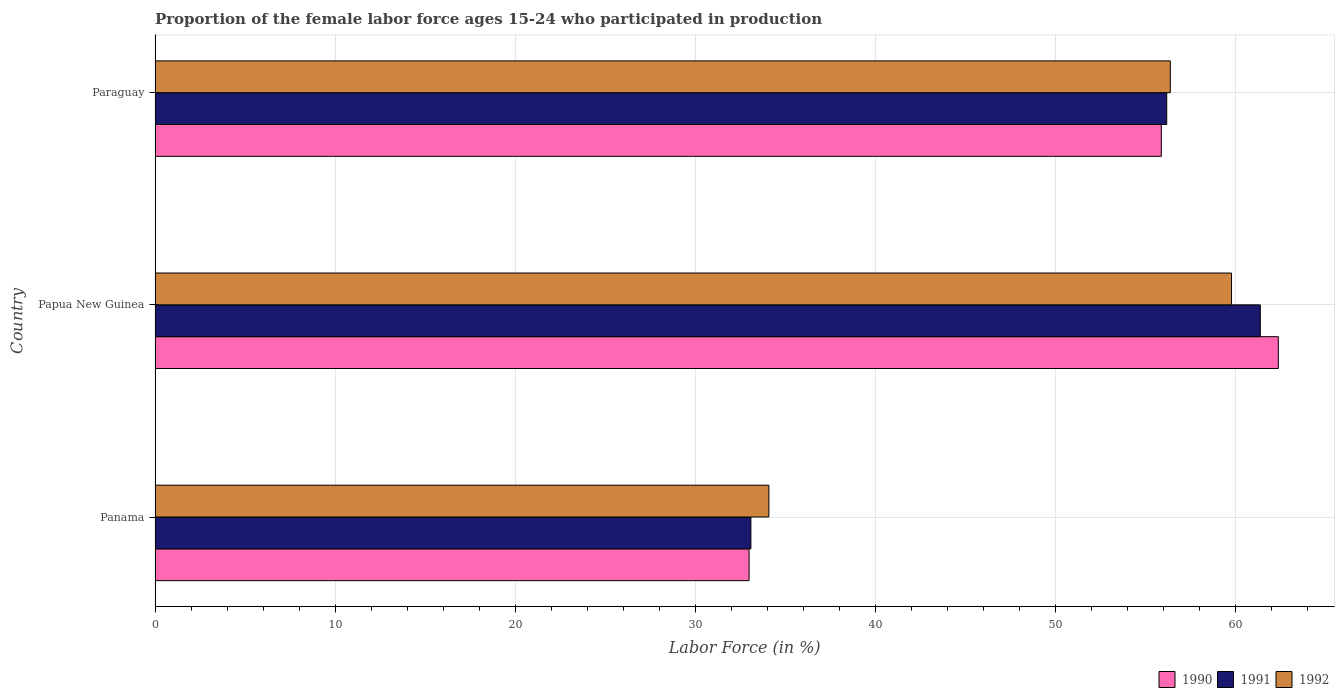How many different coloured bars are there?
Your answer should be very brief. 3. How many groups of bars are there?
Make the answer very short. 3. Are the number of bars per tick equal to the number of legend labels?
Offer a very short reply. Yes. How many bars are there on the 1st tick from the top?
Keep it short and to the point. 3. How many bars are there on the 1st tick from the bottom?
Make the answer very short. 3. What is the label of the 1st group of bars from the top?
Your answer should be compact. Paraguay. In how many cases, is the number of bars for a given country not equal to the number of legend labels?
Your response must be concise. 0. What is the proportion of the female labor force who participated in production in 1992 in Panama?
Make the answer very short. 34.1. Across all countries, what is the maximum proportion of the female labor force who participated in production in 1992?
Provide a short and direct response. 59.8. Across all countries, what is the minimum proportion of the female labor force who participated in production in 1990?
Your response must be concise. 33. In which country was the proportion of the female labor force who participated in production in 1991 maximum?
Your answer should be compact. Papua New Guinea. In which country was the proportion of the female labor force who participated in production in 1992 minimum?
Your response must be concise. Panama. What is the total proportion of the female labor force who participated in production in 1991 in the graph?
Your answer should be compact. 150.7. What is the difference between the proportion of the female labor force who participated in production in 1991 in Papua New Guinea and that in Paraguay?
Your answer should be compact. 5.2. What is the difference between the proportion of the female labor force who participated in production in 1990 in Panama and the proportion of the female labor force who participated in production in 1991 in Papua New Guinea?
Give a very brief answer. -28.4. What is the average proportion of the female labor force who participated in production in 1992 per country?
Offer a terse response. 50.1. What is the difference between the proportion of the female labor force who participated in production in 1991 and proportion of the female labor force who participated in production in 1992 in Papua New Guinea?
Give a very brief answer. 1.6. In how many countries, is the proportion of the female labor force who participated in production in 1990 greater than 46 %?
Make the answer very short. 2. What is the ratio of the proportion of the female labor force who participated in production in 1990 in Panama to that in Paraguay?
Offer a terse response. 0.59. Is the proportion of the female labor force who participated in production in 1992 in Panama less than that in Paraguay?
Keep it short and to the point. Yes. Is the difference between the proportion of the female labor force who participated in production in 1991 in Panama and Paraguay greater than the difference between the proportion of the female labor force who participated in production in 1992 in Panama and Paraguay?
Keep it short and to the point. No. What is the difference between the highest and the second highest proportion of the female labor force who participated in production in 1992?
Provide a succinct answer. 3.4. What is the difference between the highest and the lowest proportion of the female labor force who participated in production in 1991?
Keep it short and to the point. 28.3. In how many countries, is the proportion of the female labor force who participated in production in 1990 greater than the average proportion of the female labor force who participated in production in 1990 taken over all countries?
Give a very brief answer. 2. Is the sum of the proportion of the female labor force who participated in production in 1991 in Papua New Guinea and Paraguay greater than the maximum proportion of the female labor force who participated in production in 1990 across all countries?
Your response must be concise. Yes. How many bars are there?
Ensure brevity in your answer.  9. What is the difference between two consecutive major ticks on the X-axis?
Give a very brief answer. 10. Are the values on the major ticks of X-axis written in scientific E-notation?
Your response must be concise. No. How many legend labels are there?
Provide a succinct answer. 3. How are the legend labels stacked?
Your answer should be very brief. Horizontal. What is the title of the graph?
Offer a very short reply. Proportion of the female labor force ages 15-24 who participated in production. Does "1968" appear as one of the legend labels in the graph?
Make the answer very short. No. What is the label or title of the X-axis?
Give a very brief answer. Labor Force (in %). What is the Labor Force (in %) of 1990 in Panama?
Provide a short and direct response. 33. What is the Labor Force (in %) in 1991 in Panama?
Provide a short and direct response. 33.1. What is the Labor Force (in %) in 1992 in Panama?
Your response must be concise. 34.1. What is the Labor Force (in %) in 1990 in Papua New Guinea?
Your response must be concise. 62.4. What is the Labor Force (in %) in 1991 in Papua New Guinea?
Make the answer very short. 61.4. What is the Labor Force (in %) of 1992 in Papua New Guinea?
Make the answer very short. 59.8. What is the Labor Force (in %) of 1990 in Paraguay?
Your answer should be very brief. 55.9. What is the Labor Force (in %) of 1991 in Paraguay?
Provide a succinct answer. 56.2. What is the Labor Force (in %) in 1992 in Paraguay?
Your answer should be compact. 56.4. Across all countries, what is the maximum Labor Force (in %) in 1990?
Give a very brief answer. 62.4. Across all countries, what is the maximum Labor Force (in %) of 1991?
Ensure brevity in your answer.  61.4. Across all countries, what is the maximum Labor Force (in %) in 1992?
Provide a short and direct response. 59.8. Across all countries, what is the minimum Labor Force (in %) of 1990?
Your answer should be very brief. 33. Across all countries, what is the minimum Labor Force (in %) in 1991?
Offer a very short reply. 33.1. Across all countries, what is the minimum Labor Force (in %) in 1992?
Provide a succinct answer. 34.1. What is the total Labor Force (in %) of 1990 in the graph?
Offer a terse response. 151.3. What is the total Labor Force (in %) in 1991 in the graph?
Your answer should be very brief. 150.7. What is the total Labor Force (in %) in 1992 in the graph?
Keep it short and to the point. 150.3. What is the difference between the Labor Force (in %) of 1990 in Panama and that in Papua New Guinea?
Your answer should be very brief. -29.4. What is the difference between the Labor Force (in %) of 1991 in Panama and that in Papua New Guinea?
Provide a short and direct response. -28.3. What is the difference between the Labor Force (in %) of 1992 in Panama and that in Papua New Guinea?
Make the answer very short. -25.7. What is the difference between the Labor Force (in %) of 1990 in Panama and that in Paraguay?
Offer a very short reply. -22.9. What is the difference between the Labor Force (in %) of 1991 in Panama and that in Paraguay?
Make the answer very short. -23.1. What is the difference between the Labor Force (in %) of 1992 in Panama and that in Paraguay?
Keep it short and to the point. -22.3. What is the difference between the Labor Force (in %) of 1990 in Papua New Guinea and that in Paraguay?
Give a very brief answer. 6.5. What is the difference between the Labor Force (in %) of 1991 in Papua New Guinea and that in Paraguay?
Keep it short and to the point. 5.2. What is the difference between the Labor Force (in %) of 1990 in Panama and the Labor Force (in %) of 1991 in Papua New Guinea?
Give a very brief answer. -28.4. What is the difference between the Labor Force (in %) of 1990 in Panama and the Labor Force (in %) of 1992 in Papua New Guinea?
Offer a very short reply. -26.8. What is the difference between the Labor Force (in %) in 1991 in Panama and the Labor Force (in %) in 1992 in Papua New Guinea?
Your answer should be compact. -26.7. What is the difference between the Labor Force (in %) in 1990 in Panama and the Labor Force (in %) in 1991 in Paraguay?
Provide a short and direct response. -23.2. What is the difference between the Labor Force (in %) of 1990 in Panama and the Labor Force (in %) of 1992 in Paraguay?
Ensure brevity in your answer.  -23.4. What is the difference between the Labor Force (in %) of 1991 in Panama and the Labor Force (in %) of 1992 in Paraguay?
Keep it short and to the point. -23.3. What is the difference between the Labor Force (in %) of 1990 in Papua New Guinea and the Labor Force (in %) of 1991 in Paraguay?
Your response must be concise. 6.2. What is the average Labor Force (in %) of 1990 per country?
Offer a very short reply. 50.43. What is the average Labor Force (in %) of 1991 per country?
Keep it short and to the point. 50.23. What is the average Labor Force (in %) in 1992 per country?
Your answer should be very brief. 50.1. What is the difference between the Labor Force (in %) of 1991 and Labor Force (in %) of 1992 in Panama?
Your answer should be compact. -1. What is the difference between the Labor Force (in %) in 1990 and Labor Force (in %) in 1991 in Papua New Guinea?
Your answer should be compact. 1. What is the difference between the Labor Force (in %) in 1990 and Labor Force (in %) in 1991 in Paraguay?
Keep it short and to the point. -0.3. What is the difference between the Labor Force (in %) of 1990 and Labor Force (in %) of 1992 in Paraguay?
Make the answer very short. -0.5. What is the difference between the Labor Force (in %) of 1991 and Labor Force (in %) of 1992 in Paraguay?
Ensure brevity in your answer.  -0.2. What is the ratio of the Labor Force (in %) of 1990 in Panama to that in Papua New Guinea?
Make the answer very short. 0.53. What is the ratio of the Labor Force (in %) of 1991 in Panama to that in Papua New Guinea?
Offer a very short reply. 0.54. What is the ratio of the Labor Force (in %) in 1992 in Panama to that in Papua New Guinea?
Your response must be concise. 0.57. What is the ratio of the Labor Force (in %) of 1990 in Panama to that in Paraguay?
Make the answer very short. 0.59. What is the ratio of the Labor Force (in %) in 1991 in Panama to that in Paraguay?
Your answer should be compact. 0.59. What is the ratio of the Labor Force (in %) of 1992 in Panama to that in Paraguay?
Give a very brief answer. 0.6. What is the ratio of the Labor Force (in %) in 1990 in Papua New Guinea to that in Paraguay?
Give a very brief answer. 1.12. What is the ratio of the Labor Force (in %) of 1991 in Papua New Guinea to that in Paraguay?
Your response must be concise. 1.09. What is the ratio of the Labor Force (in %) of 1992 in Papua New Guinea to that in Paraguay?
Give a very brief answer. 1.06. What is the difference between the highest and the lowest Labor Force (in %) in 1990?
Your response must be concise. 29.4. What is the difference between the highest and the lowest Labor Force (in %) in 1991?
Your answer should be compact. 28.3. What is the difference between the highest and the lowest Labor Force (in %) of 1992?
Ensure brevity in your answer.  25.7. 